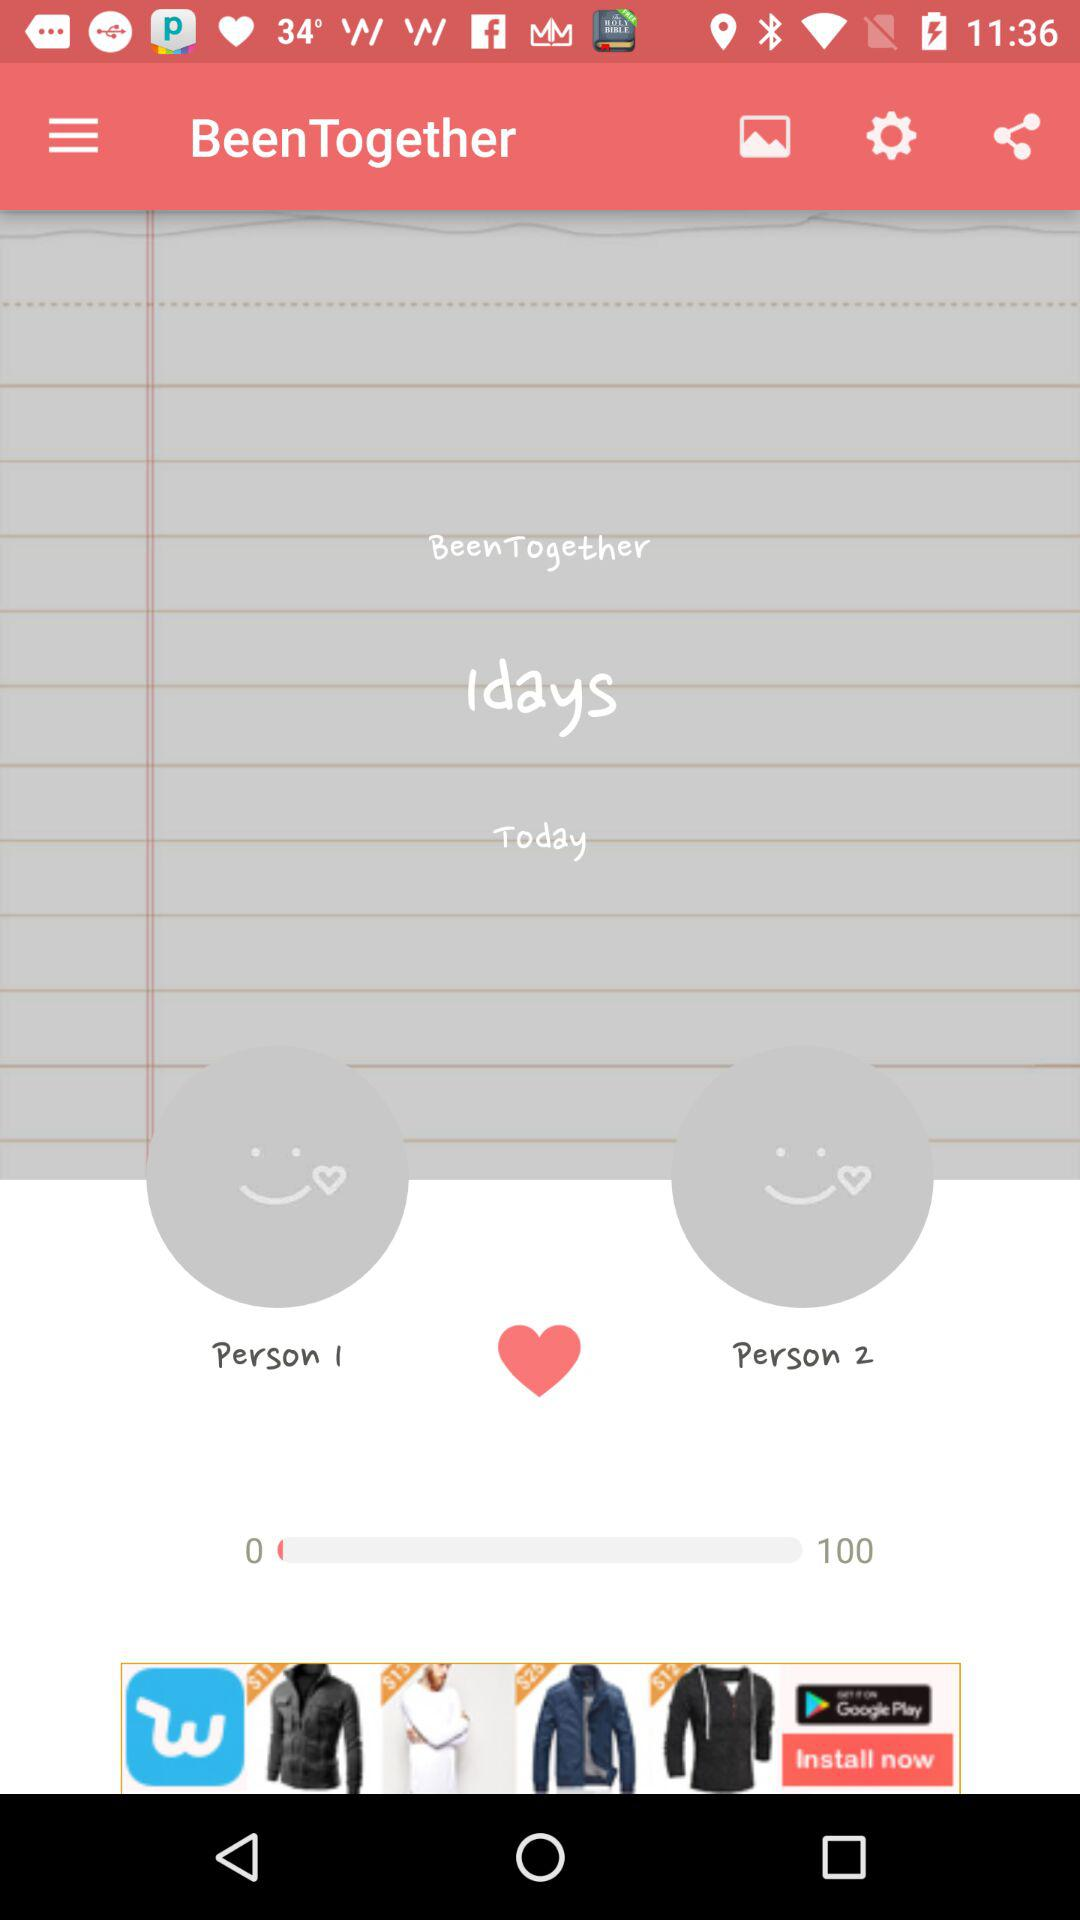What is the name of the application? The name of the application is "BeenTogether". 